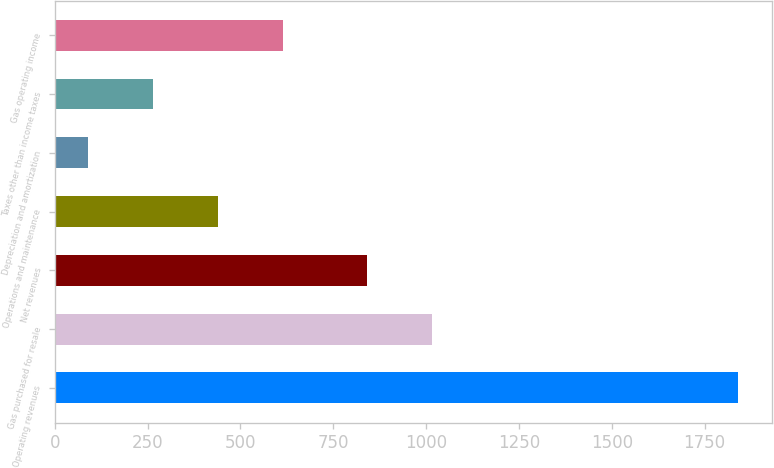Convert chart to OTSL. <chart><loc_0><loc_0><loc_500><loc_500><bar_chart><fcel>Operating revenues<fcel>Gas purchased for resale<fcel>Net revenues<fcel>Operations and maintenance<fcel>Depreciation and amortization<fcel>Taxes other than income taxes<fcel>Gas operating income<nl><fcel>1839<fcel>1014.9<fcel>840<fcel>439.8<fcel>90<fcel>264.9<fcel>614.7<nl></chart> 